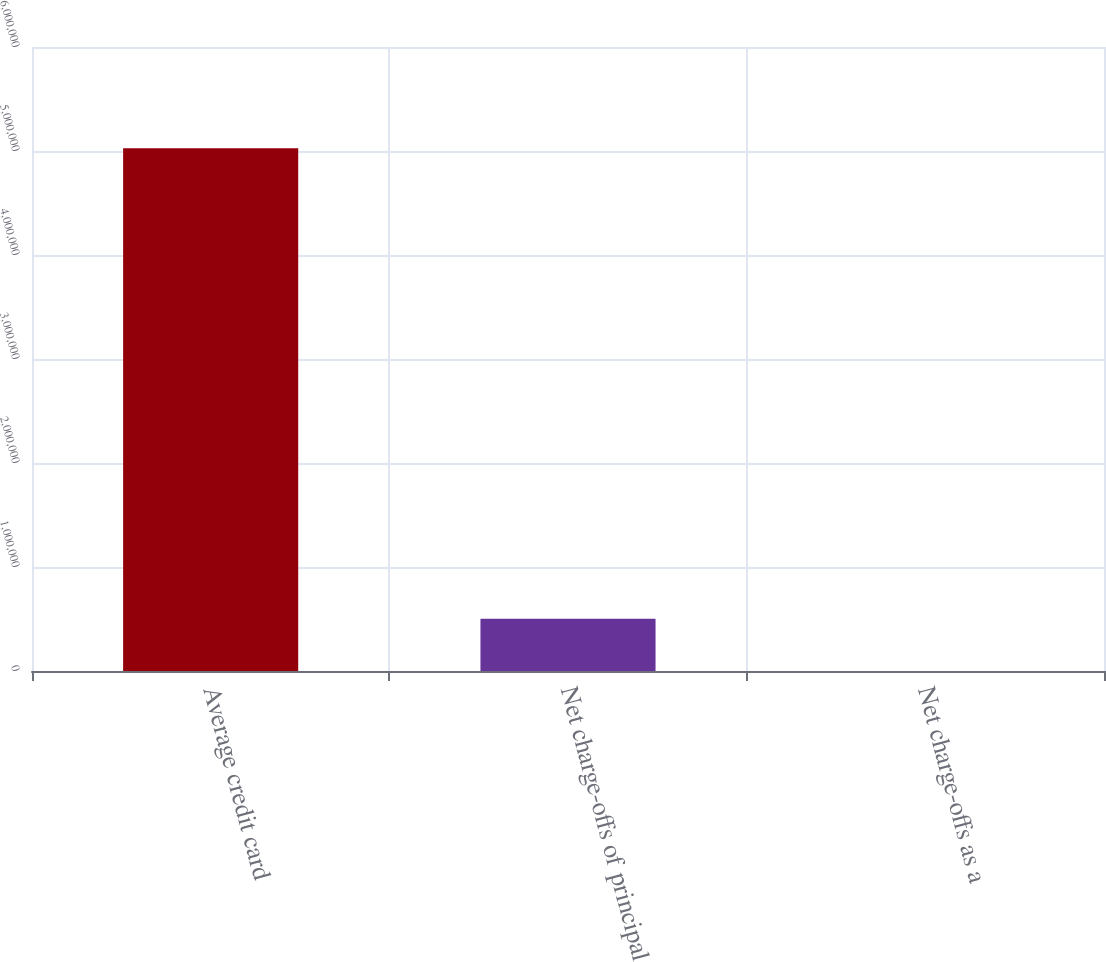<chart> <loc_0><loc_0><loc_500><loc_500><bar_chart><fcel>Average credit card<fcel>Net charge-offs of principal<fcel>Net charge-offs as a<nl><fcel>5.02592e+06<fcel>502600<fcel>8.9<nl></chart> 